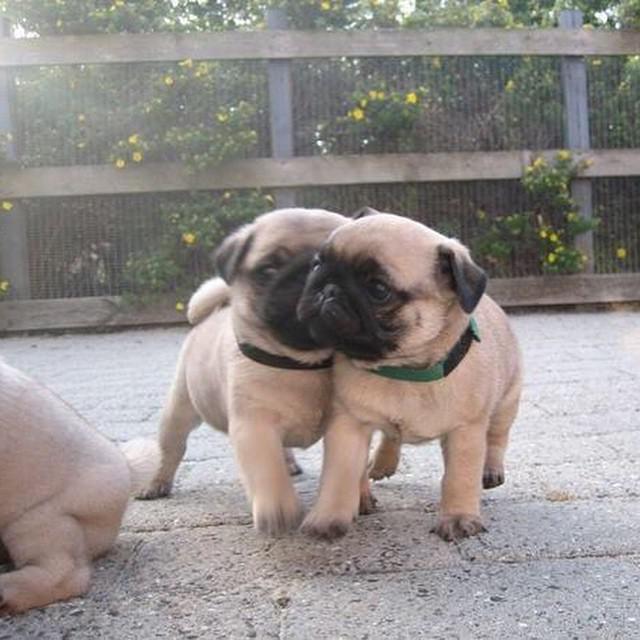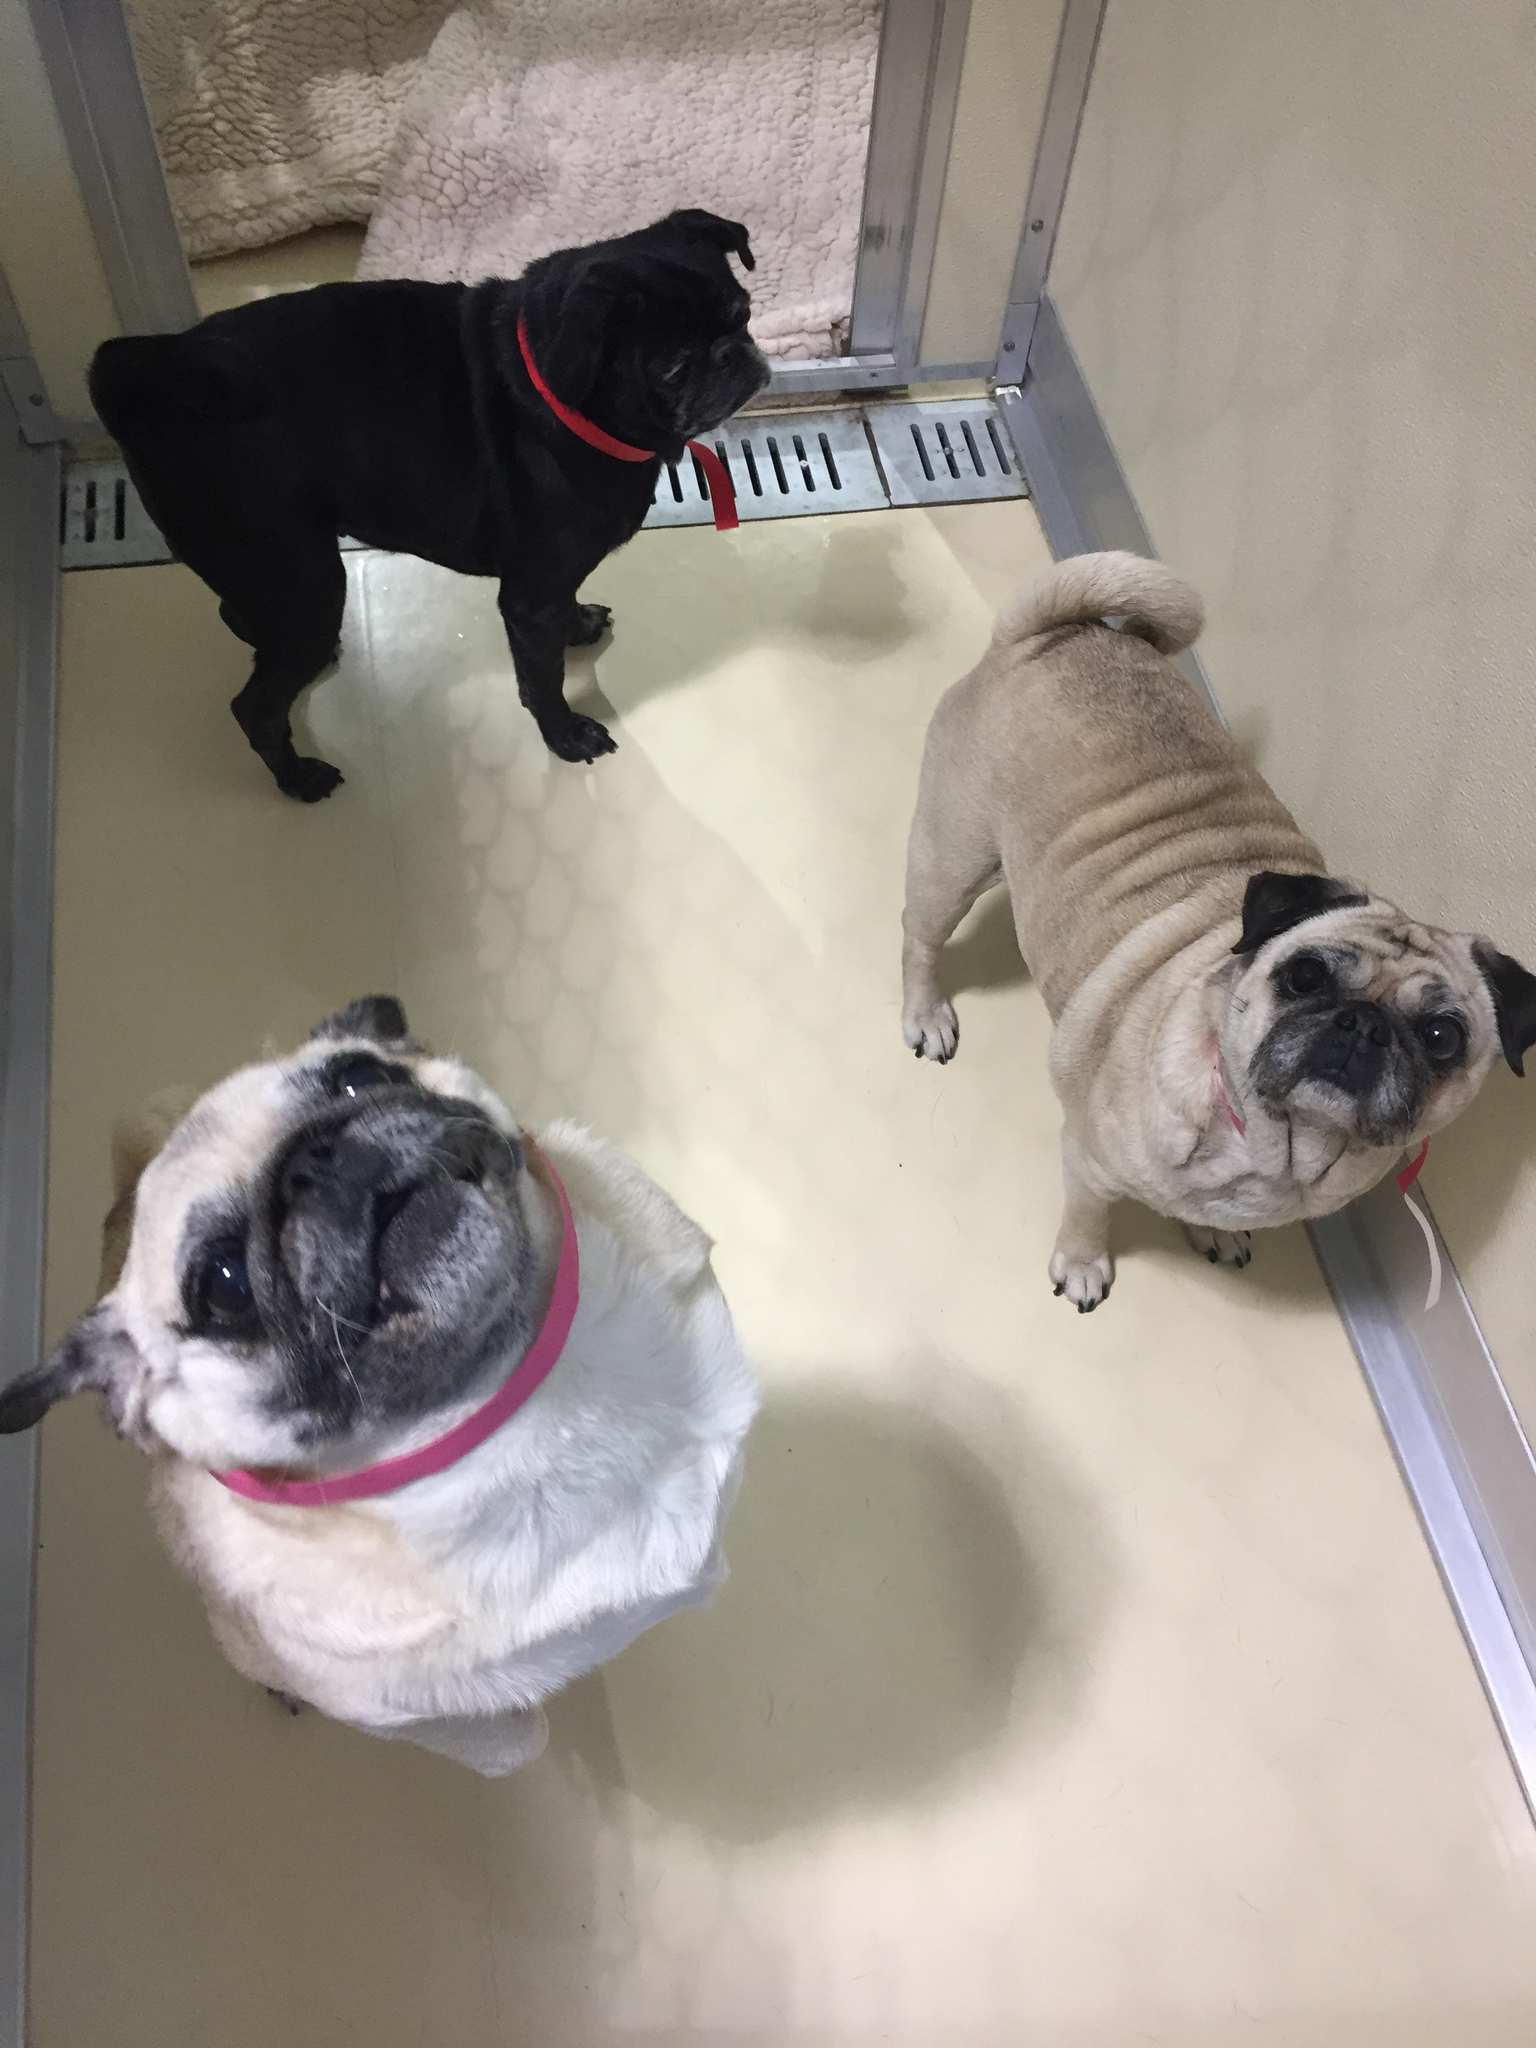The first image is the image on the left, the second image is the image on the right. For the images shown, is this caption "In at least one image there are three pugs sharing one dog bed." true? Answer yes or no. No. The first image is the image on the left, the second image is the image on the right. Examine the images to the left and right. Is the description "All dogs shown are buff-beige pugs with darker muzzles, and one image contains three pugs sitting upright, while the other image contains at least two pugs on a type of bed." accurate? Answer yes or no. No. 